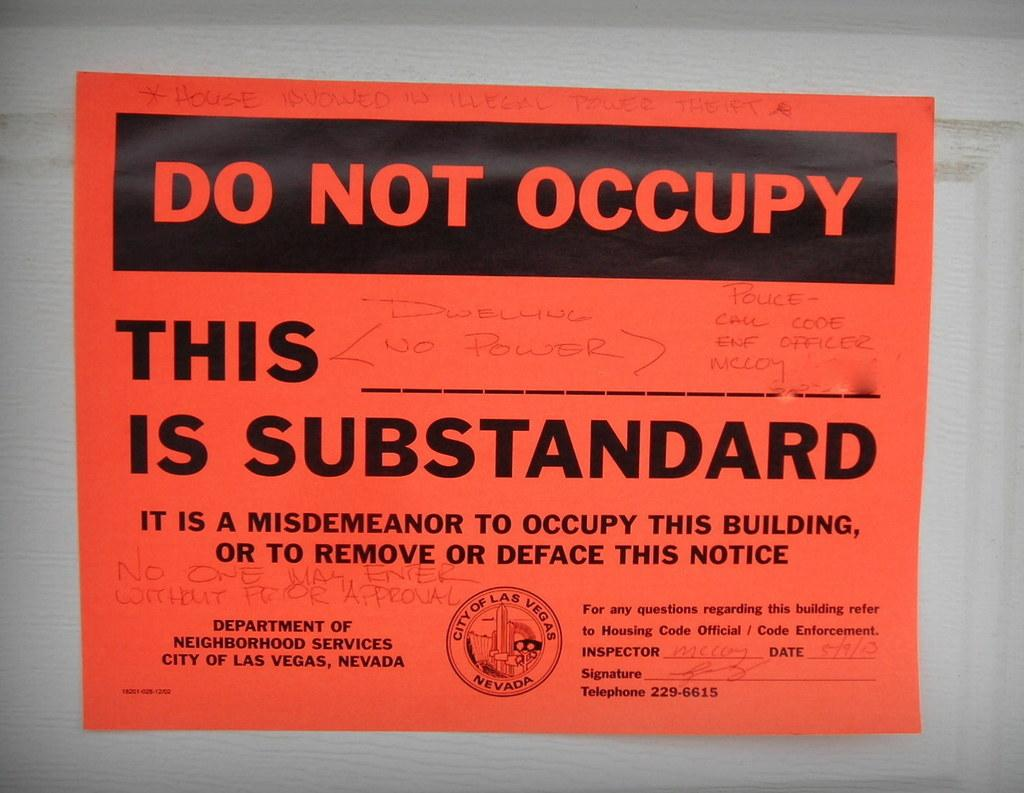Provide a one-sentence caption for the provided image. A piece of paper that says "Do not occupy" on it. 